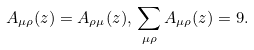<formula> <loc_0><loc_0><loc_500><loc_500>A _ { \mu \rho } ( z ) = A _ { \rho \mu } ( z ) , \, \sum _ { \mu \rho } A _ { \mu \rho } ( z ) = 9 .</formula> 